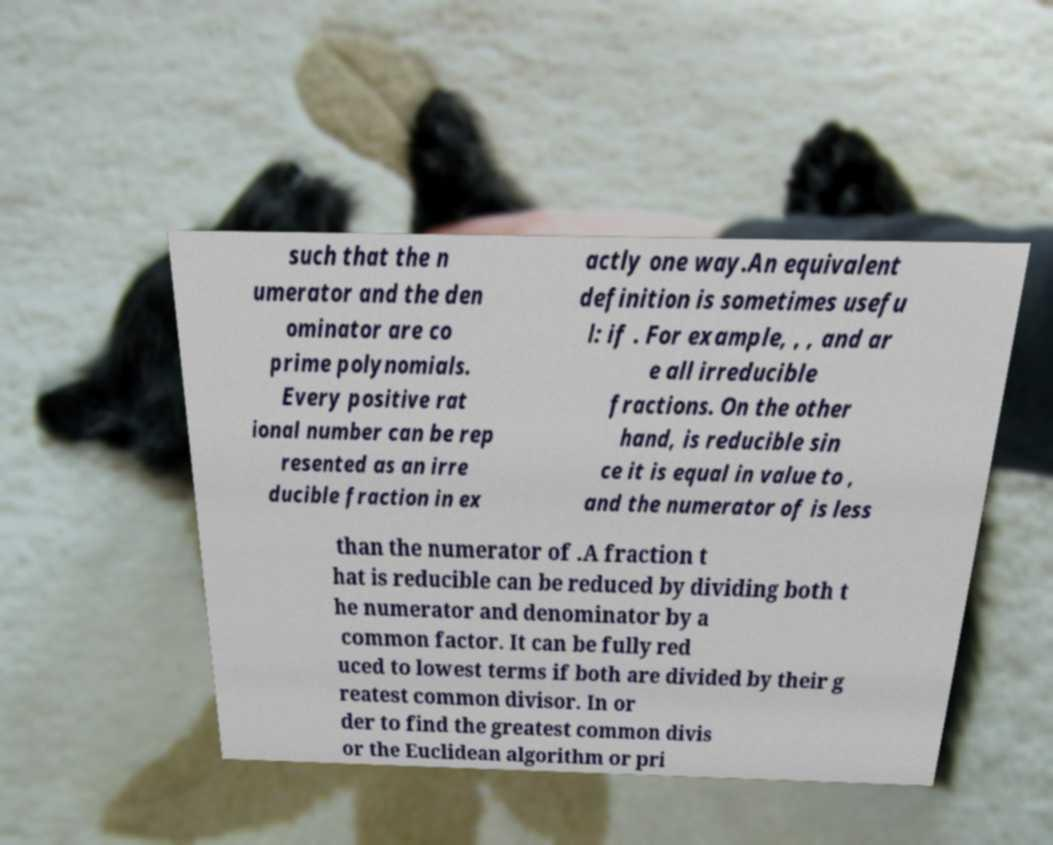There's text embedded in this image that I need extracted. Can you transcribe it verbatim? such that the n umerator and the den ominator are co prime polynomials. Every positive rat ional number can be rep resented as an irre ducible fraction in ex actly one way.An equivalent definition is sometimes usefu l: if . For example, , , and ar e all irreducible fractions. On the other hand, is reducible sin ce it is equal in value to , and the numerator of is less than the numerator of .A fraction t hat is reducible can be reduced by dividing both t he numerator and denominator by a common factor. It can be fully red uced to lowest terms if both are divided by their g reatest common divisor. In or der to find the greatest common divis or the Euclidean algorithm or pri 